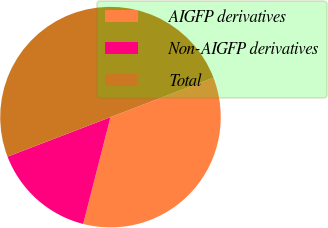Convert chart. <chart><loc_0><loc_0><loc_500><loc_500><pie_chart><fcel>AIGFP derivatives<fcel>Non-AIGFP derivatives<fcel>Total<nl><fcel>34.82%<fcel>15.18%<fcel>50.0%<nl></chart> 